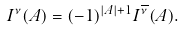Convert formula to latex. <formula><loc_0><loc_0><loc_500><loc_500>I ^ { \nu } ( A ) = ( - 1 ) ^ { | A | + 1 } I ^ { \overline { \nu } } ( A ) .</formula> 